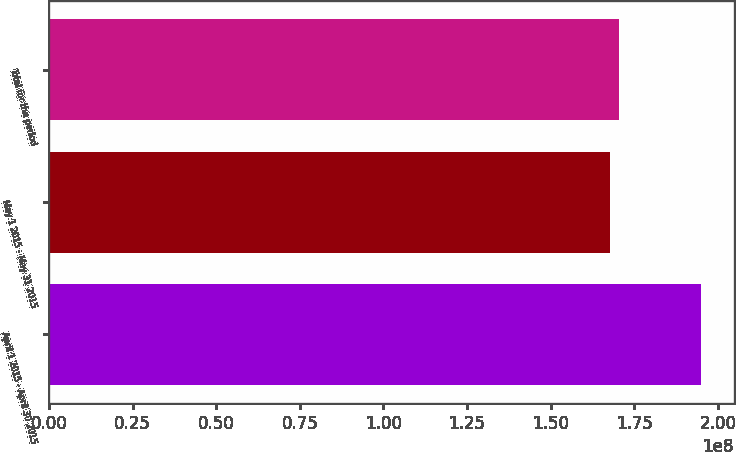Convert chart. <chart><loc_0><loc_0><loc_500><loc_500><bar_chart><fcel>April 1 2015 - April 30 2015<fcel>May 1 2015 - May 31 2015<fcel>Total for the period<nl><fcel>1.95038e+08<fcel>1.67604e+08<fcel>1.70347e+08<nl></chart> 